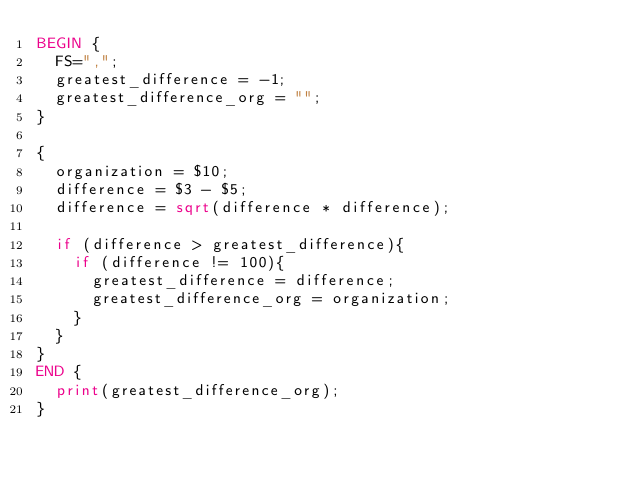<code> <loc_0><loc_0><loc_500><loc_500><_Awk_>BEGIN { 
  FS=",";
  greatest_difference = -1;
  greatest_difference_org = "";
}

{
  organization = $10;
  difference = $3 - $5;
  difference = sqrt(difference * difference);

  if (difference > greatest_difference){
    if (difference != 100){
      greatest_difference = difference;
      greatest_difference_org = organization;
    }
  }
}
END { 
  print(greatest_difference_org);
}
</code> 